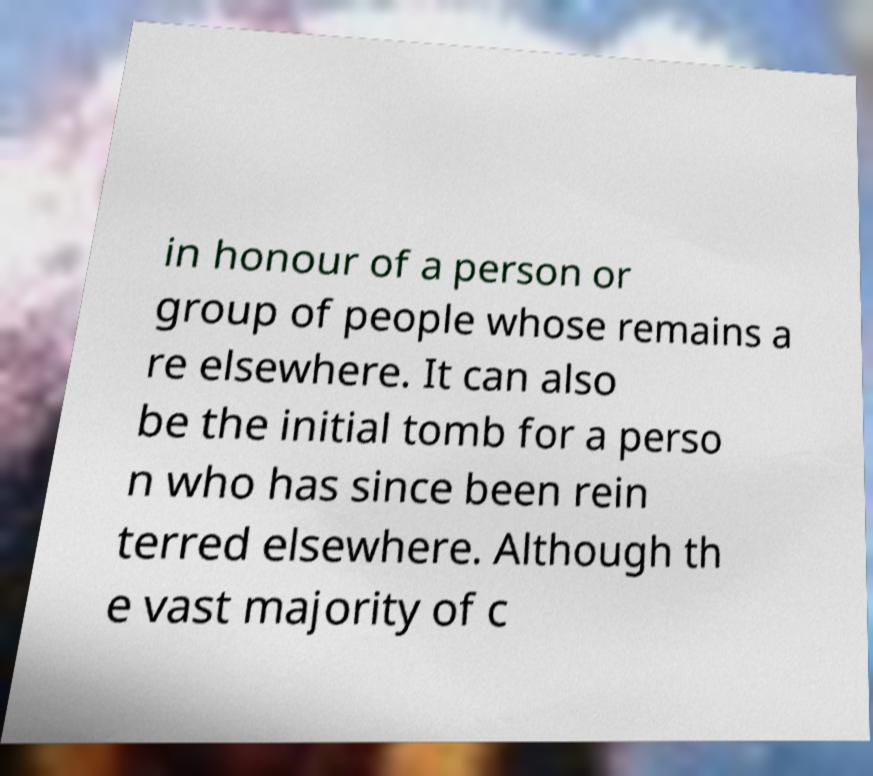Can you read and provide the text displayed in the image?This photo seems to have some interesting text. Can you extract and type it out for me? in honour of a person or group of people whose remains a re elsewhere. It can also be the initial tomb for a perso n who has since been rein terred elsewhere. Although th e vast majority of c 